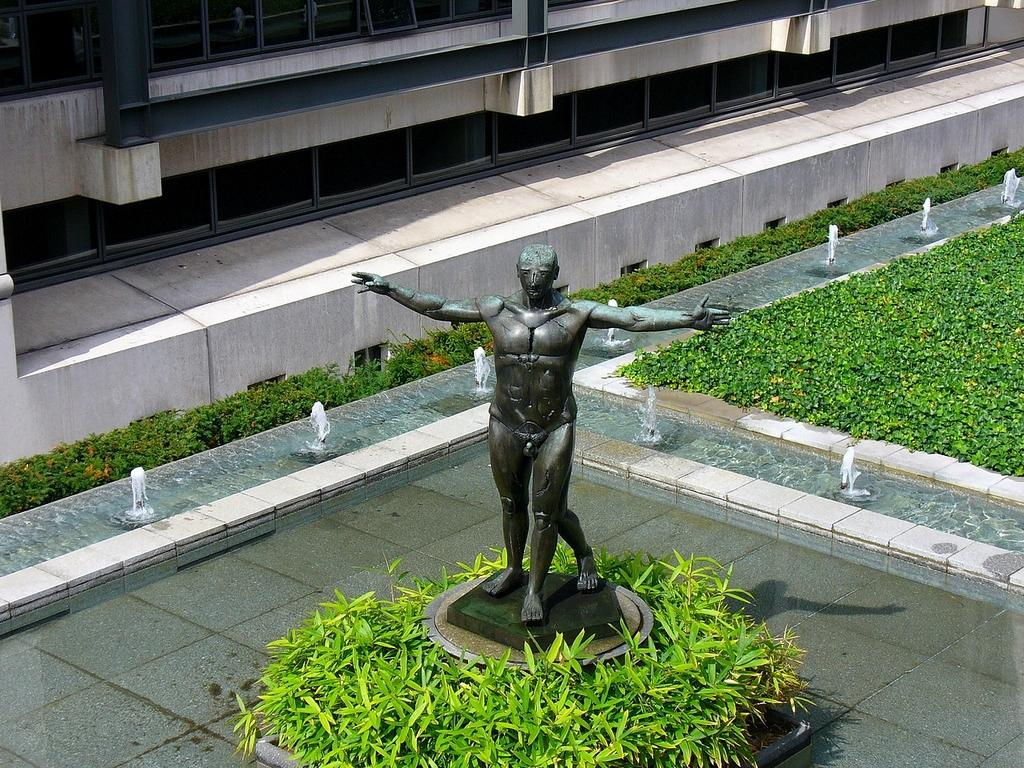What is the main subject in the image? There is a statue in the image. What is surrounding the statue? There is water and plants around the statue. What other structure can be seen in the image? There is a building in the image. How many beds are visible in the image? There are no beds present in the image. 